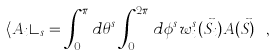Convert formula to latex. <formula><loc_0><loc_0><loc_500><loc_500>\langle A _ { i } \rangle _ { s } = \int _ { 0 } ^ { \pi } d \theta ^ { s } \int _ { 0 } ^ { 2 \pi } d \phi ^ { s } w ^ { s } _ { i } ( \vec { S } _ { i } ) A ( \vec { S } ) \ ,</formula> 